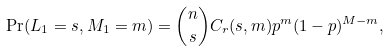<formula> <loc_0><loc_0><loc_500><loc_500>\Pr ( L _ { 1 } = s , M _ { 1 } = m ) = \binom { n } { s } C _ { r } ( s , m ) p ^ { m } ( 1 - p ) ^ { M - m } ,</formula> 